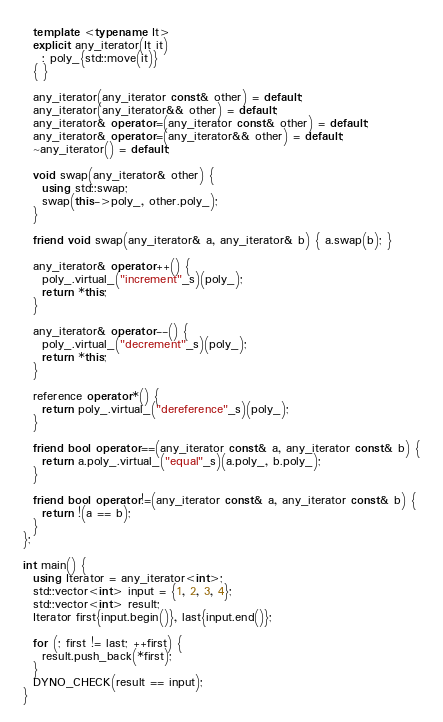Convert code to text. <code><loc_0><loc_0><loc_500><loc_500><_C++_>  template <typename It>
  explicit any_iterator(It it)
    : poly_{std::move(it)}
  { }

  any_iterator(any_iterator const& other) = default;
  any_iterator(any_iterator&& other) = default;
  any_iterator& operator=(any_iterator const& other) = default;
  any_iterator& operator=(any_iterator&& other) = default;
  ~any_iterator() = default;

  void swap(any_iterator& other) {
    using std::swap;
    swap(this->poly_, other.poly_);
  }

  friend void swap(any_iterator& a, any_iterator& b) { a.swap(b); }

  any_iterator& operator++() {
    poly_.virtual_("increment"_s)(poly_);
    return *this;
  }

  any_iterator& operator--() {
    poly_.virtual_("decrement"_s)(poly_);
    return *this;
  }

  reference operator*() {
    return poly_.virtual_("dereference"_s)(poly_);
  }

  friend bool operator==(any_iterator const& a, any_iterator const& b) {
    return a.poly_.virtual_("equal"_s)(a.poly_, b.poly_);
  }

  friend bool operator!=(any_iterator const& a, any_iterator const& b) {
    return !(a == b);
  }
};

int main() {
  using Iterator = any_iterator<int>;
  std::vector<int> input = {1, 2, 3, 4};
  std::vector<int> result;
  Iterator first{input.begin()}, last{input.end()};

  for (; first != last; ++first) {
    result.push_back(*first);
  }
  DYNO_CHECK(result == input);
}
</code> 